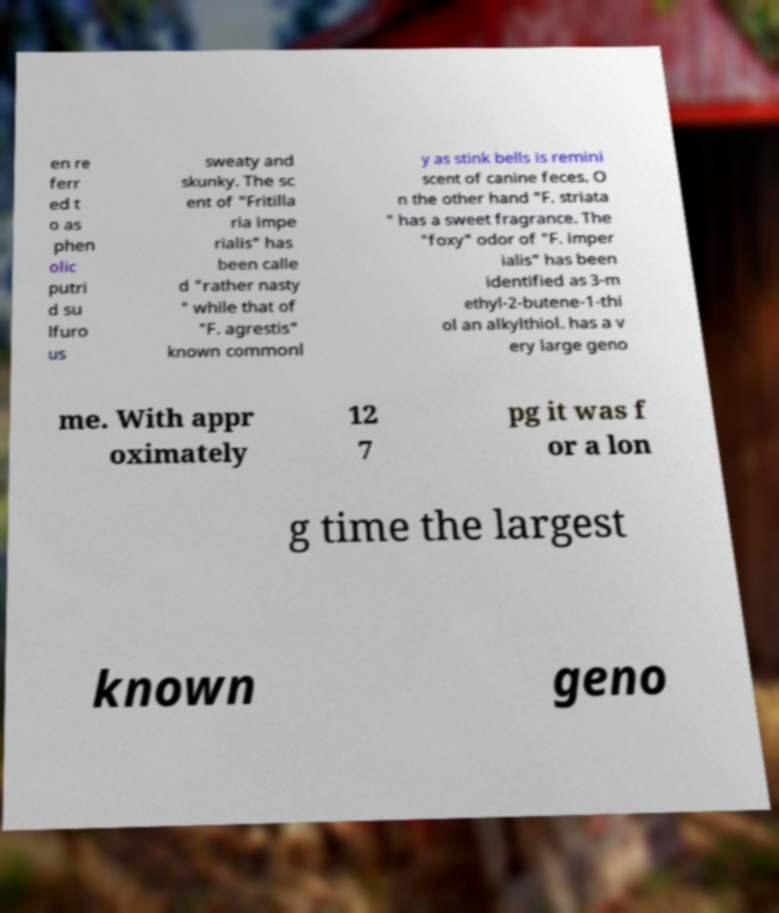I need the written content from this picture converted into text. Can you do that? en re ferr ed t o as phen olic putri d su lfuro us sweaty and skunky. The sc ent of "Fritilla ria impe rialis" has been calle d "rather nasty " while that of "F. agrestis" known commonl y as stink bells is remini scent of canine feces. O n the other hand "F. striata " has a sweet fragrance. The "foxy" odor of "F. imper ialis" has been identified as 3-m ethyl-2-butene-1-thi ol an alkylthiol. has a v ery large geno me. With appr oximately 12 7 pg it was f or a lon g time the largest known geno 